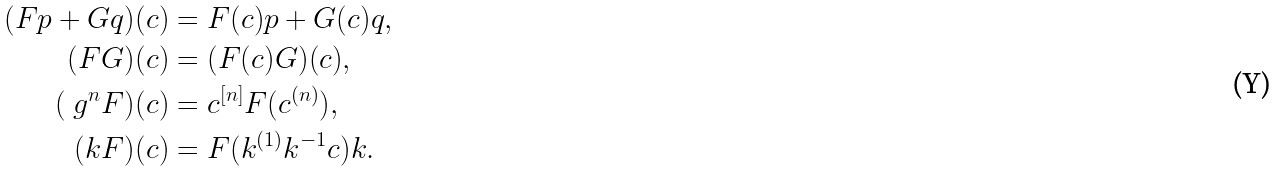<formula> <loc_0><loc_0><loc_500><loc_500>( F { p } + G { q } ) ( { c } ) & = F ( { c } ) { p } + G ( { c } ) { q } , \\ ( F G ) ( { c } ) & = ( F ( { c } ) G ) ( { c } ) , \\ ( \ g ^ { n } F ) ( { c } ) & = { c } ^ { [ n ] } F ( { c } ^ { ( n ) } ) , \\ ( { k } F ) ( { c } ) & = F ( { k } ^ { ( 1 ) } { k } ^ { - 1 } { c } ) { k } .</formula> 